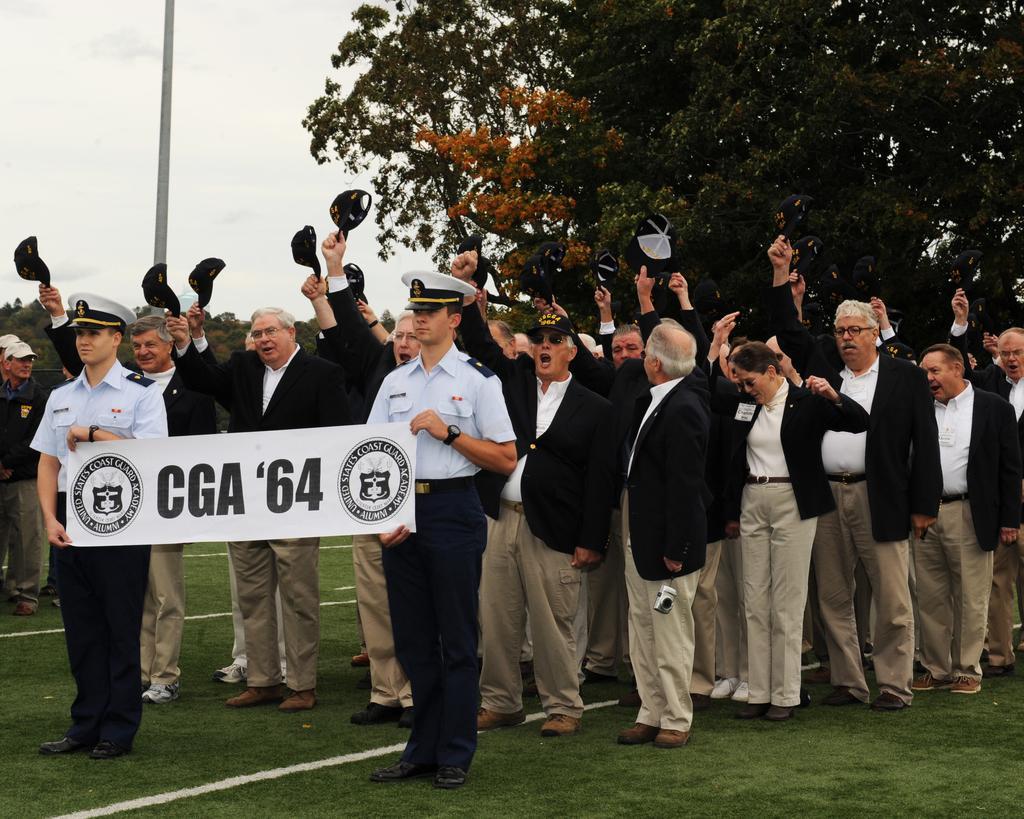How would you summarize this image in a sentence or two? There are two men holding a flex in the foreground area of the image, there are people holding caps behind them on the grassland, there are trees, a pole and the sky in the background. 